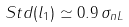Convert formula to latex. <formula><loc_0><loc_0><loc_500><loc_500>S t d ( l _ { 1 } ) \simeq 0 . 9 \, \sigma _ { n L }</formula> 